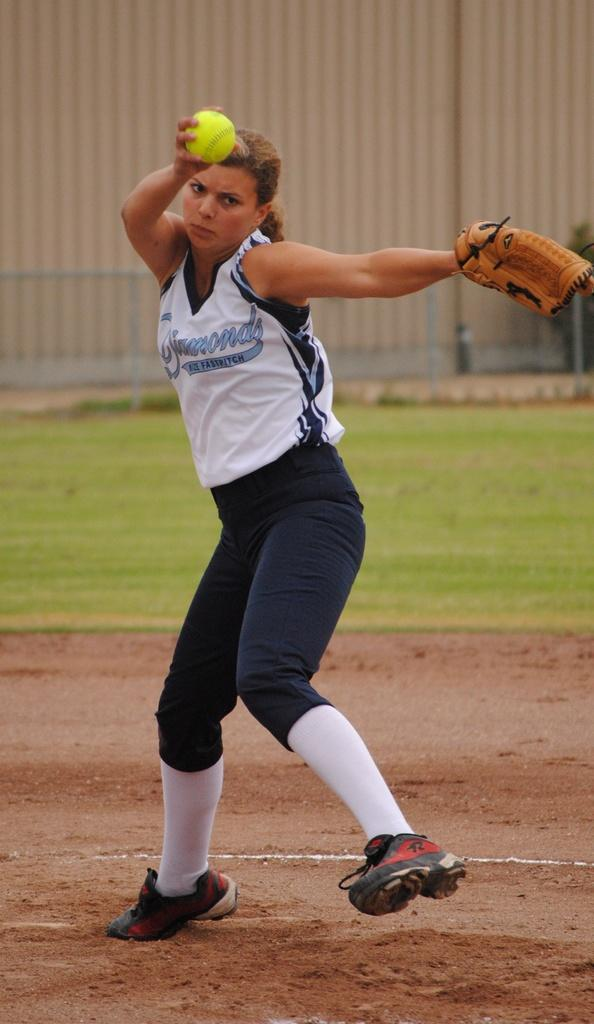Provide a one-sentence caption for the provided image. The pitcher for the Diamonds softball team gets ready to deliver a pitch. 